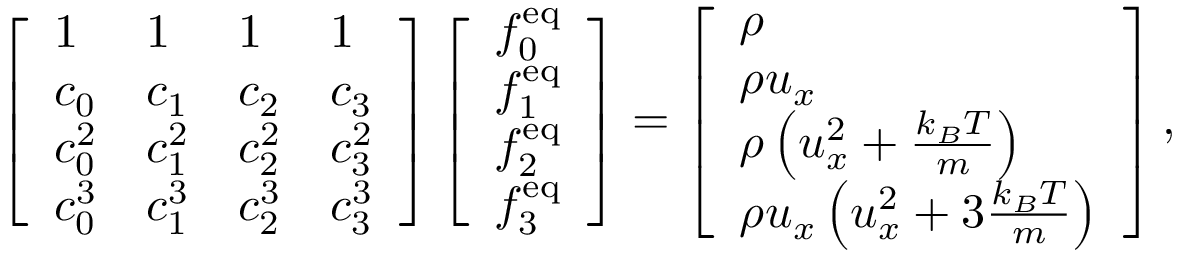Convert formula to latex. <formula><loc_0><loc_0><loc_500><loc_500>\left [ \begin{array} { l l l l } { 1 } & { 1 } & { 1 } & { 1 } \\ { c _ { 0 } } & { c _ { 1 } } & { c _ { 2 } } & { c _ { 3 } } \\ { c _ { 0 } ^ { 2 } } & { c _ { 1 } ^ { 2 } } & { c _ { 2 } ^ { 2 } } & { c _ { 3 } ^ { 2 } } \\ { c _ { 0 } ^ { 3 } } & { c _ { 1 } ^ { 3 } } & { c _ { 2 } ^ { 3 } } & { c _ { 3 } ^ { 3 } } \end{array} \right ] \left [ \begin{array} { l } { f _ { 0 } ^ { e q } } \\ { f _ { 1 } ^ { e q } } \\ { f _ { 2 } ^ { e q } } \\ { f _ { 3 } ^ { e q } } \end{array} \right ] = \left [ \begin{array} { l } { \rho } \\ { \rho u _ { x } } \\ { \rho \left ( u _ { x } ^ { 2 } + \frac { k _ { B } T } { m } \right ) } \\ { \rho u _ { x } \left ( u _ { x } ^ { 2 } + 3 \frac { k _ { B } T } { m } \right ) } \end{array} \right ] ,</formula> 